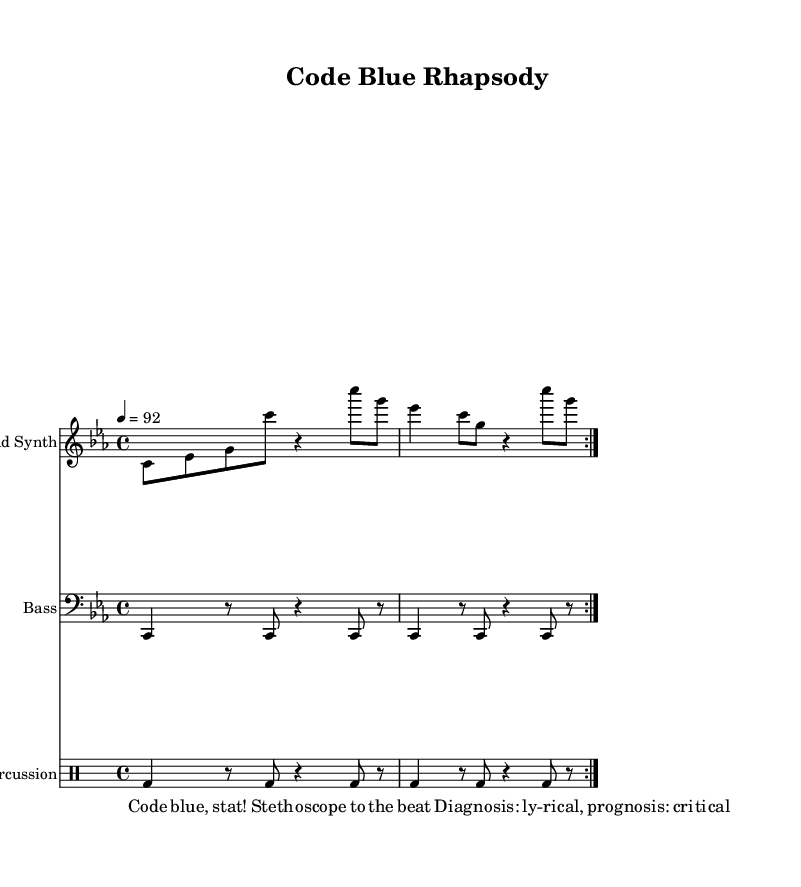What is the key signature of this music? The key signature is C minor, which is indicated with three flats on the staff.
Answer: C minor What is the time signature of this piece? The time signature is 4/4, which is shown at the beginning of the score. This indicates that there are four beats in each measure.
Answer: 4/4 What is the tempo marking for this piece? The tempo is marked as quarter note = 92, indicating the speed at which the piece should be played.
Answer: 92 How many measures are repeated in the lead synth part? The lead synth part includes a repeat indication marked at the beginning of the section and is indicated as "volta 2," meaning it is played twice.
Answer: 2 What type of drum is indicated in the percussion section? The percussion section uses a bass drum, which is referred to as "bd" in the notation.
Answer: Bass drum What term is used to describe the medical urgency in the lyrics? The lyrics feature the term "Code blue," commonly used in hospitals to indicate a medical emergency requiring immediate attention.
Answer: Code blue What type of musical genre does this piece represent? This piece represents experimental rap, which is characterized by its incorporation of unconventional sounds, including medical terminology and hospital noises.
Answer: Experimental rap 